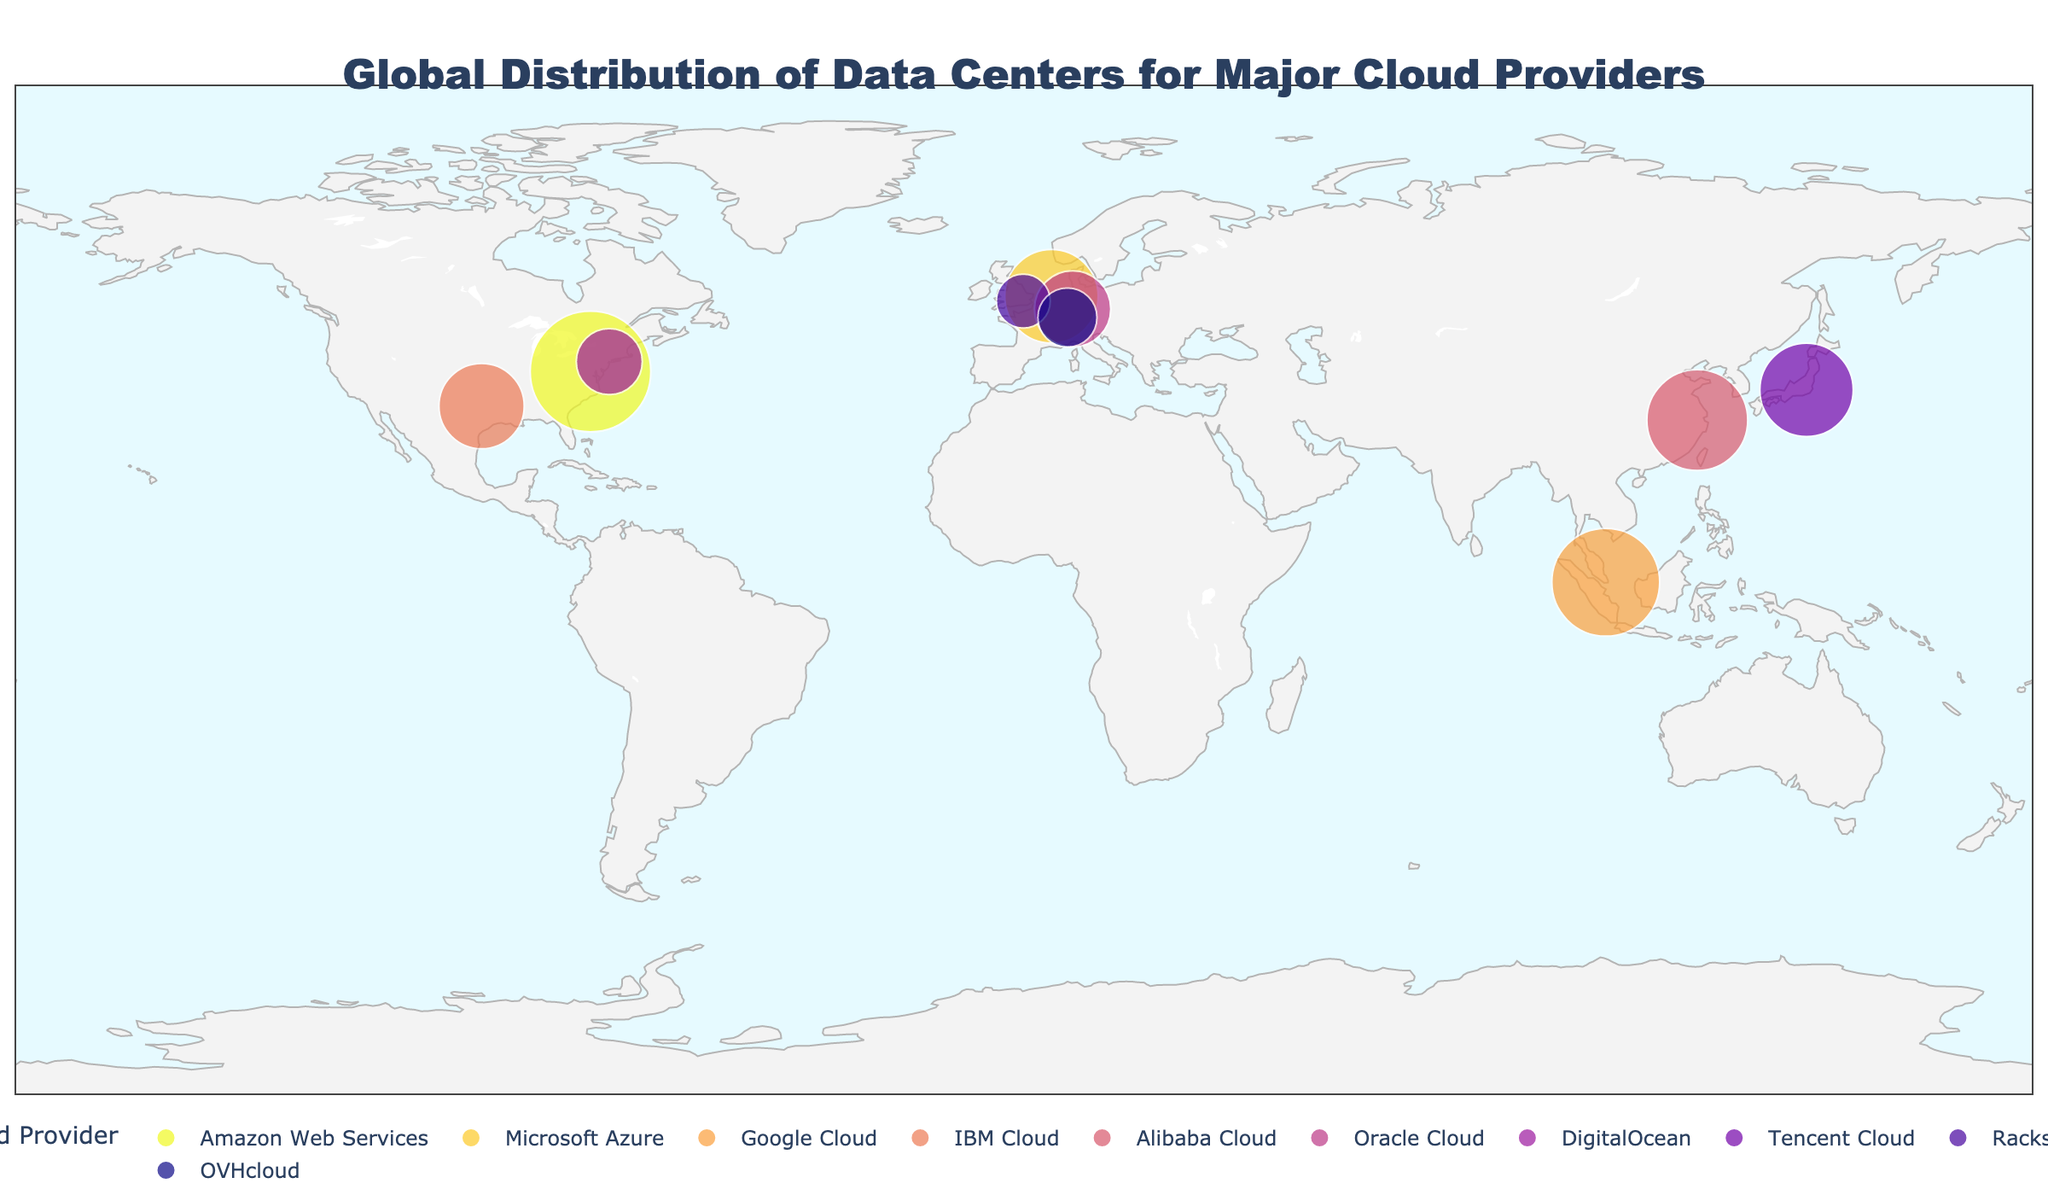Which cloud provider has the highest server count in the plot? The plot shows various providers along with the size of their markers proportional to their server counts. By examining the plot, Amazon Web Services (AWS) has the largest marker, indicating the highest server count.
Answer: Amazon Web Services What is the title of the figure? The title is displayed prominently at the top of the figure and summarizes its purpose. The title reads "Global Distribution of Data Centers for Major Cloud Providers".
Answer: Global Distribution of Data Centers for Major Cloud Providers How many server locations are there in total on the plot? The plot contains markers corresponding to each server location. By counting these markers, you can determine there are 10 server locations represented.
Answer: 10 Which data center location has the smallest server count, and how many servers are there? Each data center location is represented by a marker whose size indicates the server count. The smallest marker represents Rackspace in London with a server count of 10,000.
Answer: London, 10,000 What is the combined server count of the data centers located in Asia? Locations in Asia are Singapore (Google Cloud) and Hangzhou (Alibaba Cloud). Their server counts are 40,000 and 35,000 respectively. Summing these values gives 75,000.
Answer: 75,000 Which cloud providers have data centers in Europe, and what are their respective server counts? Europe-based servers are in Amsterdam (Microsoft Azure), Frankfurt (Oracle Cloud), London (Rackspace), and Strasbourg (OVHcloud). Their server counts are 30,000, 20,000, 10,000, and 12,000, respectively.
Answer: Microsoft Azure (30,000), Oracle Cloud (20,000), Rackspace (10,000), OVHcloud (12,000) Compare the server count of Google Cloud in Singapore to Microsoft Azure in Amsterdam. Which has more, and by how much? The server count for Google Cloud in Singapore is 40,000, while Microsoft Azure in Amsterdam is 30,000. Subtracting these figures (40,000 - 30,000) shows Google Cloud has 10,000 more servers.
Answer: Google Cloud by 10,000 Which cloud provider's data center is located in Texas, USA, and what is its server count? By examining the location labels on the plot, the data center in Dallas, Texas, is associated with IBM Cloud, which has a server count of 25,000.
Answer: IBM Cloud, 25,000 What is the average server count of the data centers in the plot? The server counts are 50,000, 30,000, 40,000, 25,000, 35,000, 20,000, 15,000, 30,000, 10,000, and 12,000. Summing these values gives 267,000. Dividing by 10 (the total number of data centers) gives an average of 26,700.
Answer: 26,700 Which data centers are located closer together, and what are the distances between them? Observing the geographical plot, Amsterdam (Microsoft Azure) and Frankfurt (Oracle Cloud) are relatively close. Similarly, London (Rackspace) and Strasbourg (OVHcloud) are also nearby. The approximate distances would need geographic tools to calculate precise values, but visual inspection shows these pairs are the closest.
Answer: Amsterdam and Frankfurt, London and Strasbourg 